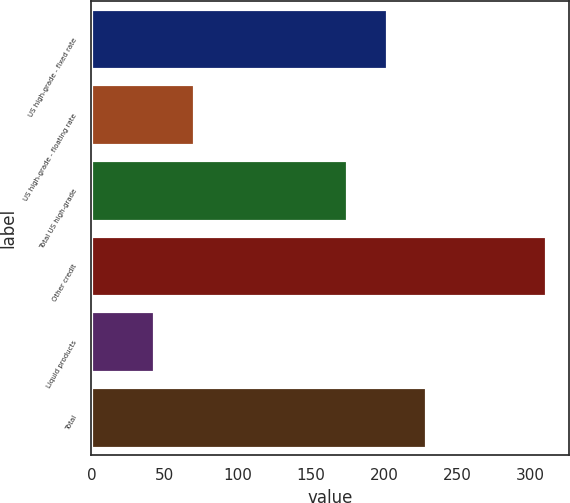Convert chart. <chart><loc_0><loc_0><loc_500><loc_500><bar_chart><fcel>US high-grade - fixed rate<fcel>US high-grade - floating rate<fcel>Total US high-grade<fcel>Other credit<fcel>Liquid products<fcel>Total<nl><fcel>201.8<fcel>69.8<fcel>175<fcel>311<fcel>43<fcel>228.6<nl></chart> 